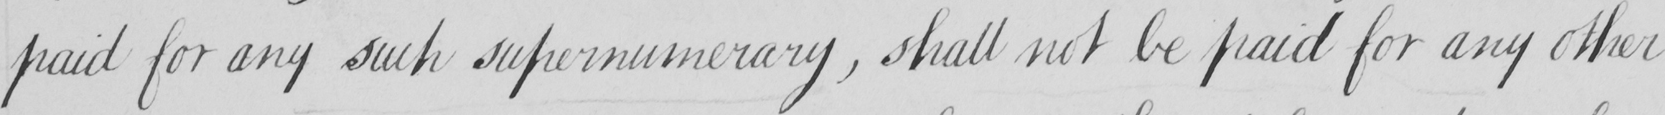Can you read and transcribe this handwriting? paid for any such supernumerary  , shall not be paid for any other 